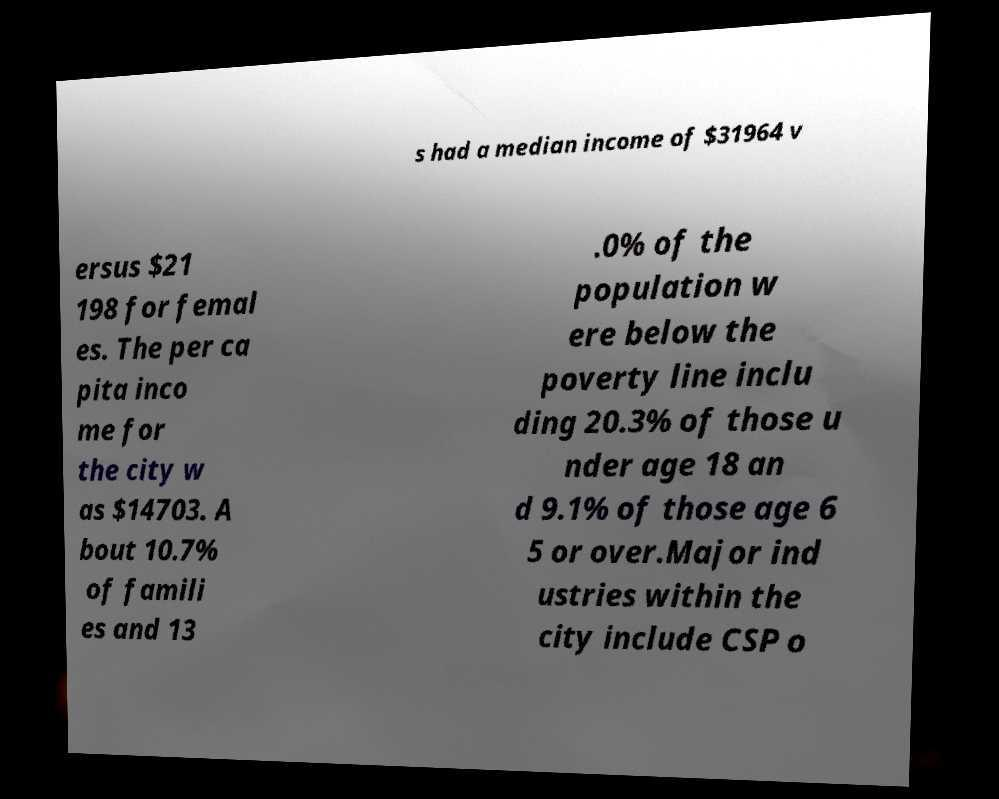Please identify and transcribe the text found in this image. s had a median income of $31964 v ersus $21 198 for femal es. The per ca pita inco me for the city w as $14703. A bout 10.7% of famili es and 13 .0% of the population w ere below the poverty line inclu ding 20.3% of those u nder age 18 an d 9.1% of those age 6 5 or over.Major ind ustries within the city include CSP o 